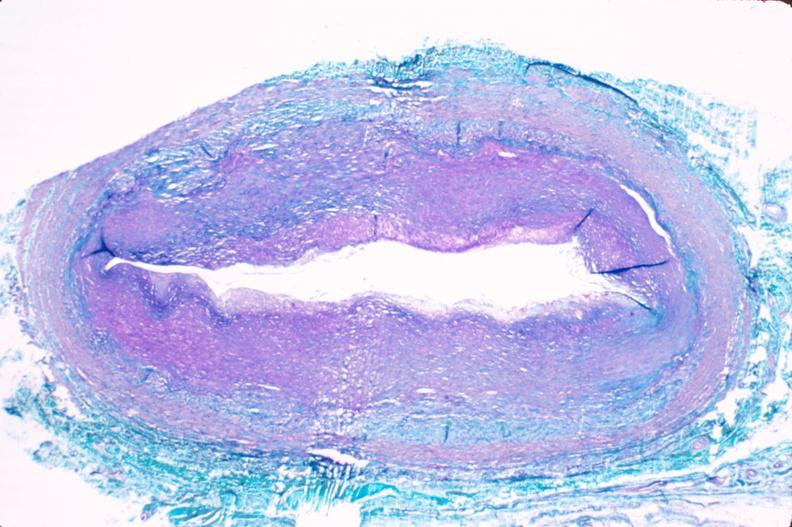where is this in?
Answer the question using a single word or phrase. In vasculature 